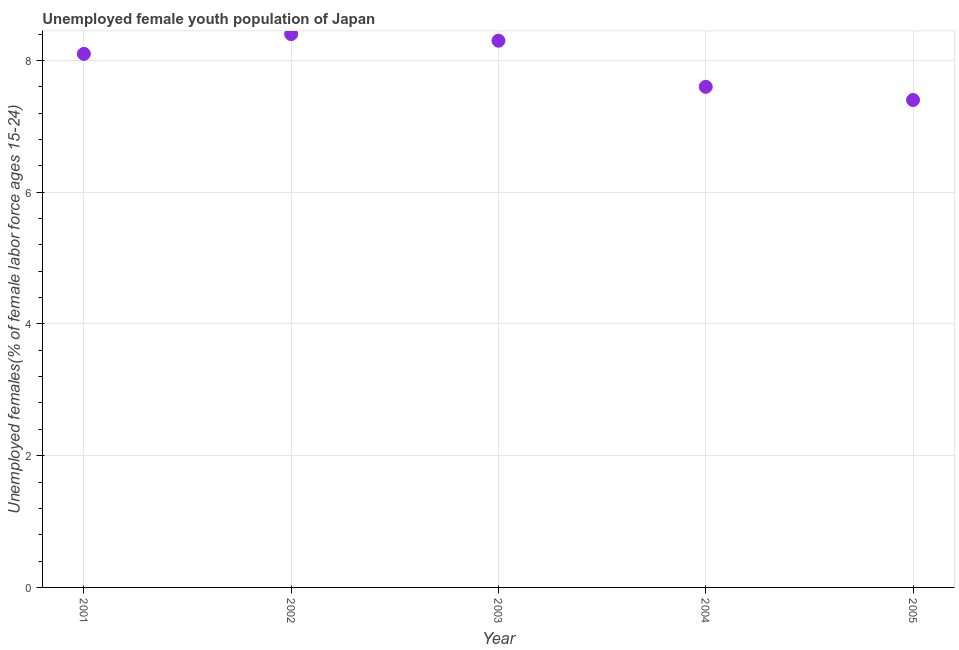What is the unemployed female youth in 2005?
Make the answer very short. 7.4. Across all years, what is the maximum unemployed female youth?
Give a very brief answer. 8.4. Across all years, what is the minimum unemployed female youth?
Your answer should be compact. 7.4. In which year was the unemployed female youth minimum?
Offer a terse response. 2005. What is the sum of the unemployed female youth?
Your response must be concise. 39.8. What is the difference between the unemployed female youth in 2002 and 2003?
Give a very brief answer. 0.1. What is the average unemployed female youth per year?
Keep it short and to the point. 7.96. What is the median unemployed female youth?
Make the answer very short. 8.1. What is the ratio of the unemployed female youth in 2001 to that in 2004?
Your answer should be compact. 1.07. Is the unemployed female youth in 2004 less than that in 2005?
Give a very brief answer. No. Is the difference between the unemployed female youth in 2003 and 2004 greater than the difference between any two years?
Your answer should be compact. No. What is the difference between the highest and the second highest unemployed female youth?
Provide a succinct answer. 0.1. What is the difference between the highest and the lowest unemployed female youth?
Offer a terse response. 1. How many dotlines are there?
Make the answer very short. 1. What is the difference between two consecutive major ticks on the Y-axis?
Make the answer very short. 2. Does the graph contain any zero values?
Provide a short and direct response. No. What is the title of the graph?
Keep it short and to the point. Unemployed female youth population of Japan. What is the label or title of the Y-axis?
Keep it short and to the point. Unemployed females(% of female labor force ages 15-24). What is the Unemployed females(% of female labor force ages 15-24) in 2001?
Your answer should be compact. 8.1. What is the Unemployed females(% of female labor force ages 15-24) in 2002?
Offer a terse response. 8.4. What is the Unemployed females(% of female labor force ages 15-24) in 2003?
Give a very brief answer. 8.3. What is the Unemployed females(% of female labor force ages 15-24) in 2004?
Make the answer very short. 7.6. What is the Unemployed females(% of female labor force ages 15-24) in 2005?
Offer a terse response. 7.4. What is the difference between the Unemployed females(% of female labor force ages 15-24) in 2001 and 2004?
Provide a succinct answer. 0.5. What is the difference between the Unemployed females(% of female labor force ages 15-24) in 2001 and 2005?
Your answer should be very brief. 0.7. What is the difference between the Unemployed females(% of female labor force ages 15-24) in 2002 and 2003?
Your response must be concise. 0.1. What is the difference between the Unemployed females(% of female labor force ages 15-24) in 2002 and 2004?
Your answer should be very brief. 0.8. What is the difference between the Unemployed females(% of female labor force ages 15-24) in 2003 and 2004?
Ensure brevity in your answer.  0.7. What is the ratio of the Unemployed females(% of female labor force ages 15-24) in 2001 to that in 2002?
Keep it short and to the point. 0.96. What is the ratio of the Unemployed females(% of female labor force ages 15-24) in 2001 to that in 2004?
Give a very brief answer. 1.07. What is the ratio of the Unemployed females(% of female labor force ages 15-24) in 2001 to that in 2005?
Provide a short and direct response. 1.09. What is the ratio of the Unemployed females(% of female labor force ages 15-24) in 2002 to that in 2004?
Your response must be concise. 1.1. What is the ratio of the Unemployed females(% of female labor force ages 15-24) in 2002 to that in 2005?
Ensure brevity in your answer.  1.14. What is the ratio of the Unemployed females(% of female labor force ages 15-24) in 2003 to that in 2004?
Your response must be concise. 1.09. What is the ratio of the Unemployed females(% of female labor force ages 15-24) in 2003 to that in 2005?
Provide a short and direct response. 1.12. What is the ratio of the Unemployed females(% of female labor force ages 15-24) in 2004 to that in 2005?
Keep it short and to the point. 1.03. 